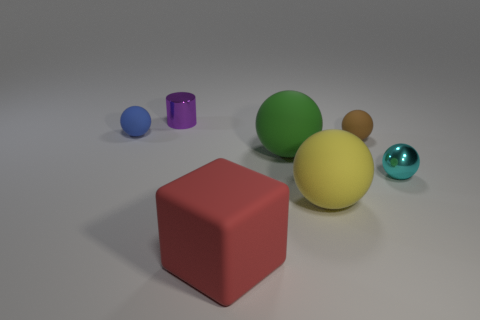Add 1 tiny shiny balls. How many objects exist? 8 Subtract all spheres. How many objects are left? 2 Subtract 0 red spheres. How many objects are left? 7 Subtract all large yellow spheres. Subtract all blue matte spheres. How many objects are left? 5 Add 3 big red rubber cubes. How many big red rubber cubes are left? 4 Add 6 yellow matte balls. How many yellow matte balls exist? 7 